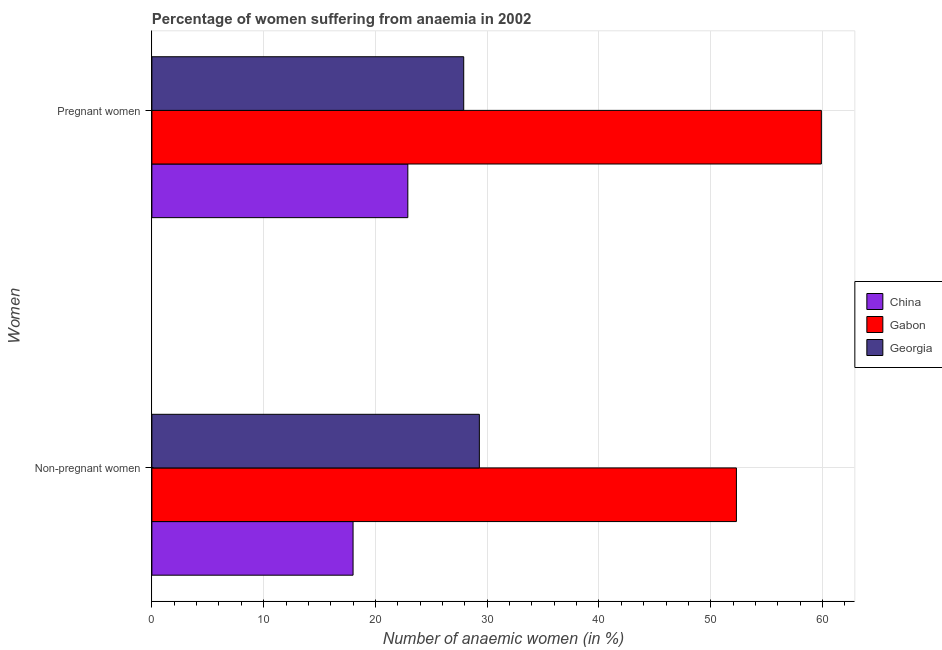How many different coloured bars are there?
Your response must be concise. 3. Are the number of bars on each tick of the Y-axis equal?
Your answer should be very brief. Yes. What is the label of the 2nd group of bars from the top?
Your answer should be compact. Non-pregnant women. What is the percentage of non-pregnant anaemic women in China?
Give a very brief answer. 18. Across all countries, what is the maximum percentage of non-pregnant anaemic women?
Your answer should be very brief. 52.3. In which country was the percentage of non-pregnant anaemic women maximum?
Offer a very short reply. Gabon. What is the total percentage of pregnant anaemic women in the graph?
Offer a terse response. 110.7. What is the difference between the percentage of non-pregnant anaemic women in Gabon and the percentage of pregnant anaemic women in China?
Your response must be concise. 29.4. What is the average percentage of pregnant anaemic women per country?
Provide a short and direct response. 36.9. What is the difference between the percentage of non-pregnant anaemic women and percentage of pregnant anaemic women in China?
Provide a short and direct response. -4.9. What is the ratio of the percentage of non-pregnant anaemic women in Georgia to that in Gabon?
Your answer should be compact. 0.56. Is the percentage of pregnant anaemic women in Georgia less than that in China?
Provide a succinct answer. No. In how many countries, is the percentage of non-pregnant anaemic women greater than the average percentage of non-pregnant anaemic women taken over all countries?
Your answer should be compact. 1. What does the 1st bar from the top in Non-pregnant women represents?
Ensure brevity in your answer.  Georgia. What does the 1st bar from the bottom in Non-pregnant women represents?
Provide a succinct answer. China. How many bars are there?
Your response must be concise. 6. Are all the bars in the graph horizontal?
Your answer should be very brief. Yes. What is the difference between two consecutive major ticks on the X-axis?
Offer a very short reply. 10. Does the graph contain grids?
Your answer should be very brief. Yes. Where does the legend appear in the graph?
Your answer should be compact. Center right. How are the legend labels stacked?
Offer a terse response. Vertical. What is the title of the graph?
Ensure brevity in your answer.  Percentage of women suffering from anaemia in 2002. Does "Nigeria" appear as one of the legend labels in the graph?
Your answer should be very brief. No. What is the label or title of the X-axis?
Your answer should be compact. Number of anaemic women (in %). What is the label or title of the Y-axis?
Provide a succinct answer. Women. What is the Number of anaemic women (in %) of China in Non-pregnant women?
Your answer should be very brief. 18. What is the Number of anaemic women (in %) in Gabon in Non-pregnant women?
Make the answer very short. 52.3. What is the Number of anaemic women (in %) in Georgia in Non-pregnant women?
Make the answer very short. 29.3. What is the Number of anaemic women (in %) of China in Pregnant women?
Offer a terse response. 22.9. What is the Number of anaemic women (in %) in Gabon in Pregnant women?
Give a very brief answer. 59.9. What is the Number of anaemic women (in %) in Georgia in Pregnant women?
Offer a terse response. 27.9. Across all Women, what is the maximum Number of anaemic women (in %) in China?
Offer a very short reply. 22.9. Across all Women, what is the maximum Number of anaemic women (in %) in Gabon?
Make the answer very short. 59.9. Across all Women, what is the maximum Number of anaemic women (in %) of Georgia?
Keep it short and to the point. 29.3. Across all Women, what is the minimum Number of anaemic women (in %) of Gabon?
Make the answer very short. 52.3. Across all Women, what is the minimum Number of anaemic women (in %) of Georgia?
Make the answer very short. 27.9. What is the total Number of anaemic women (in %) in China in the graph?
Your answer should be compact. 40.9. What is the total Number of anaemic women (in %) of Gabon in the graph?
Your answer should be very brief. 112.2. What is the total Number of anaemic women (in %) of Georgia in the graph?
Make the answer very short. 57.2. What is the difference between the Number of anaemic women (in %) of China in Non-pregnant women and that in Pregnant women?
Your answer should be compact. -4.9. What is the difference between the Number of anaemic women (in %) of Georgia in Non-pregnant women and that in Pregnant women?
Give a very brief answer. 1.4. What is the difference between the Number of anaemic women (in %) of China in Non-pregnant women and the Number of anaemic women (in %) of Gabon in Pregnant women?
Your response must be concise. -41.9. What is the difference between the Number of anaemic women (in %) in China in Non-pregnant women and the Number of anaemic women (in %) in Georgia in Pregnant women?
Provide a succinct answer. -9.9. What is the difference between the Number of anaemic women (in %) of Gabon in Non-pregnant women and the Number of anaemic women (in %) of Georgia in Pregnant women?
Offer a terse response. 24.4. What is the average Number of anaemic women (in %) of China per Women?
Offer a terse response. 20.45. What is the average Number of anaemic women (in %) of Gabon per Women?
Your answer should be very brief. 56.1. What is the average Number of anaemic women (in %) of Georgia per Women?
Offer a terse response. 28.6. What is the difference between the Number of anaemic women (in %) in China and Number of anaemic women (in %) in Gabon in Non-pregnant women?
Provide a succinct answer. -34.3. What is the difference between the Number of anaemic women (in %) of China and Number of anaemic women (in %) of Gabon in Pregnant women?
Make the answer very short. -37. What is the difference between the Number of anaemic women (in %) of Gabon and Number of anaemic women (in %) of Georgia in Pregnant women?
Offer a very short reply. 32. What is the ratio of the Number of anaemic women (in %) of China in Non-pregnant women to that in Pregnant women?
Keep it short and to the point. 0.79. What is the ratio of the Number of anaemic women (in %) in Gabon in Non-pregnant women to that in Pregnant women?
Give a very brief answer. 0.87. What is the ratio of the Number of anaemic women (in %) in Georgia in Non-pregnant women to that in Pregnant women?
Offer a very short reply. 1.05. What is the difference between the highest and the second highest Number of anaemic women (in %) in Gabon?
Ensure brevity in your answer.  7.6. What is the difference between the highest and the lowest Number of anaemic women (in %) in China?
Provide a succinct answer. 4.9. 